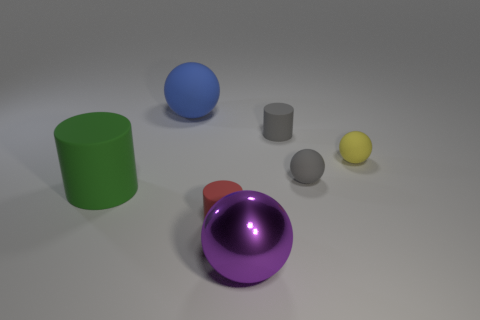Does the arrangement of objects suggest any particular pattern or purpose? The arrangement of the objects does not seem to follow a specific pattern or purpose. They are placed at varying distances from each other and do not suggest any intentional design or sequence. The scene appears to be a random collection of geometric shapes. 